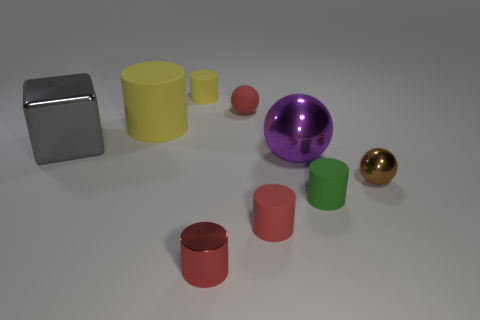Subtract 3 cylinders. How many cylinders are left? 2 Subtract all big cylinders. How many cylinders are left? 4 Subtract all green cylinders. How many cylinders are left? 4 Add 1 small objects. How many objects exist? 10 Subtract all purple cylinders. Subtract all yellow blocks. How many cylinders are left? 5 Subtract all cylinders. How many objects are left? 4 Subtract 0 cyan cylinders. How many objects are left? 9 Subtract all yellow rubber cylinders. Subtract all large red shiny balls. How many objects are left? 7 Add 3 small red rubber spheres. How many small red rubber spheres are left? 4 Add 8 purple spheres. How many purple spheres exist? 9 